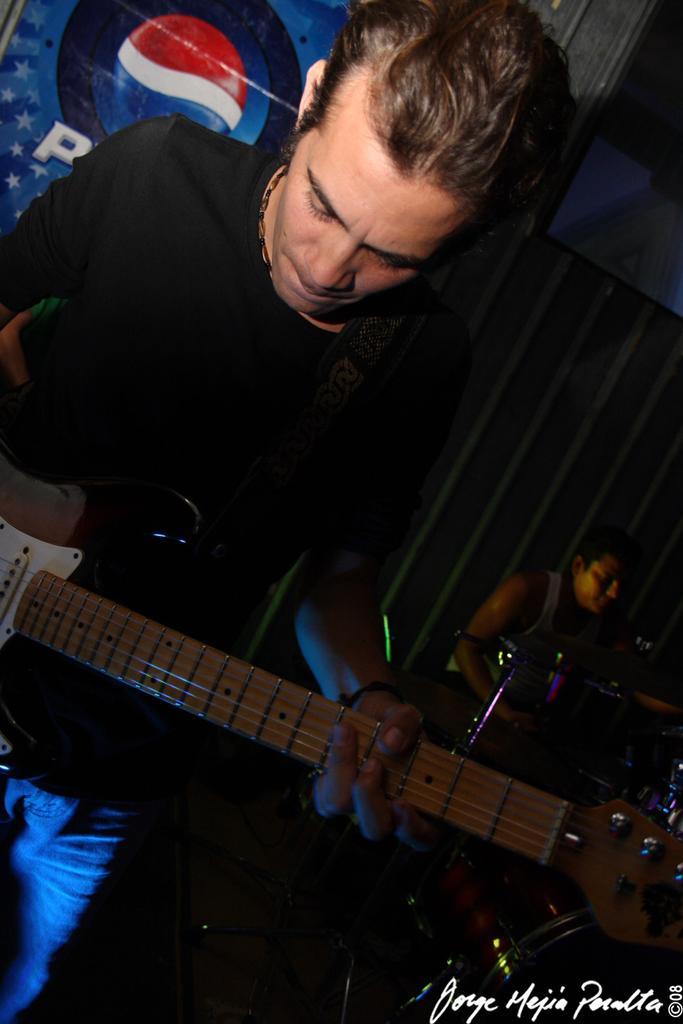Who is the main subject in the image? There is a man in the image. What is the man holding in the image? The man is holding a guitar. What can be seen in the background of the image? There are people in the background of the image. What are the people in the background doing? The people in the background are playing musical instruments. How much fuel is needed for the babies to be quiet in the image? There are no babies or fuel present in the image, and therefore no such situation can be observed. 